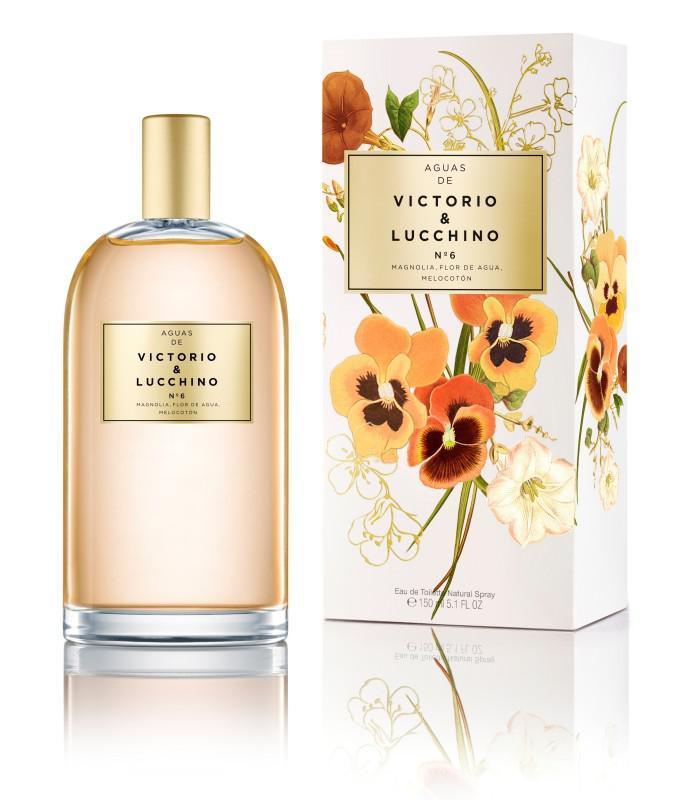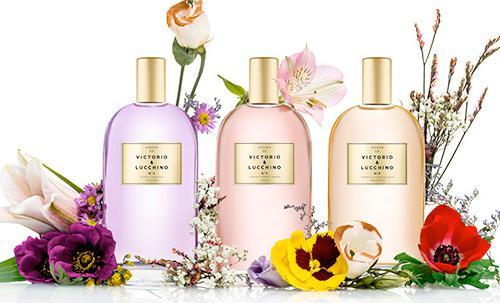The first image is the image on the left, the second image is the image on the right. Given the left and right images, does the statement "Some of the bottles are surrounded by flowers." hold true? Answer yes or no. Yes. The first image is the image on the left, the second image is the image on the right. Evaluate the accuracy of this statement regarding the images: "One of the images shows three bottles of perfume surrounded by flowers.". Is it true? Answer yes or no. Yes. 